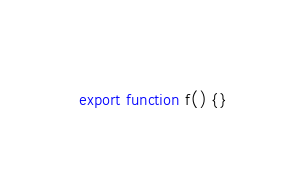<code> <loc_0><loc_0><loc_500><loc_500><_TypeScript_>export function f() {}
</code> 